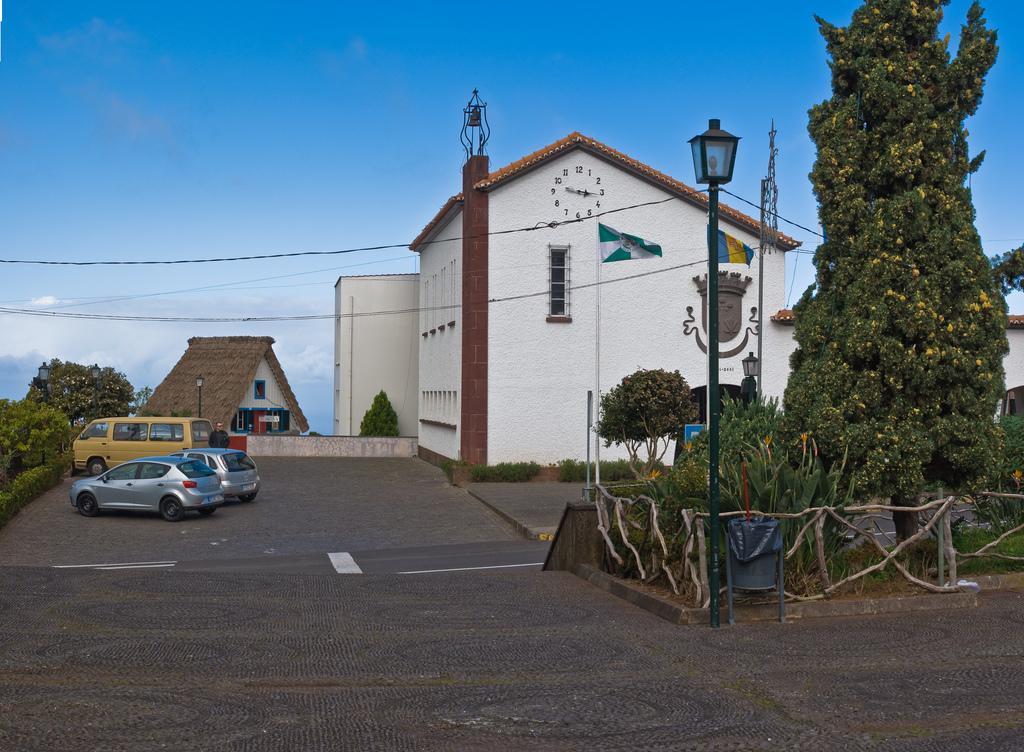Can you describe this image briefly? This picture is clicked outside. On the right we can see a tree, plants, wooden fence and a lamppost. On the left we can see the vehicles seems to be parked on the ground and a person. In the background there is a sky, buildings and plants and cables. 